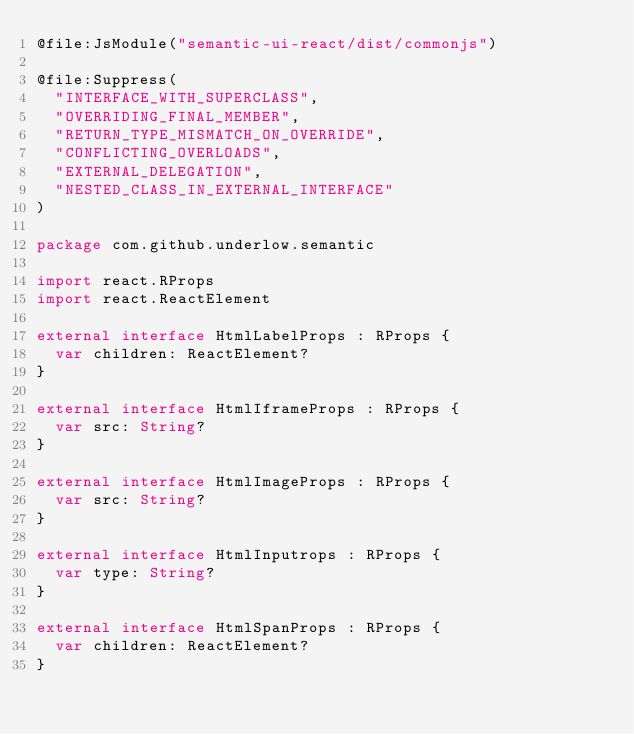Convert code to text. <code><loc_0><loc_0><loc_500><loc_500><_Kotlin_>@file:JsModule("semantic-ui-react/dist/commonjs")

@file:Suppress(
  "INTERFACE_WITH_SUPERCLASS",
  "OVERRIDING_FINAL_MEMBER",
  "RETURN_TYPE_MISMATCH_ON_OVERRIDE",
  "CONFLICTING_OVERLOADS",
  "EXTERNAL_DELEGATION",
  "NESTED_CLASS_IN_EXTERNAL_INTERFACE"
)

package com.github.underlow.semantic

import react.RProps
import react.ReactElement

external interface HtmlLabelProps : RProps {
  var children: ReactElement?
}

external interface HtmlIframeProps : RProps {
  var src: String?
}

external interface HtmlImageProps : RProps {
  var src: String?
}

external interface HtmlInputrops : RProps {
  var type: String?
}

external interface HtmlSpanProps : RProps {
  var children: ReactElement?
}
</code> 